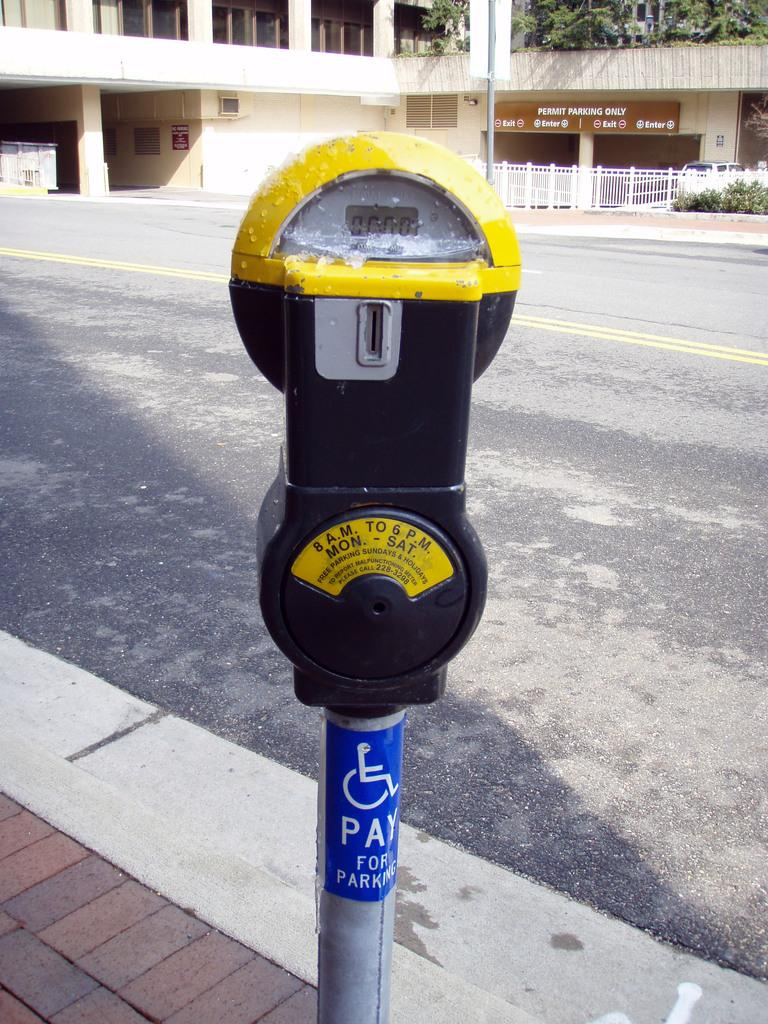<image>
Give a short and clear explanation of the subsequent image. A parking meter that is active 8am to 6pm Mon-Sat. 